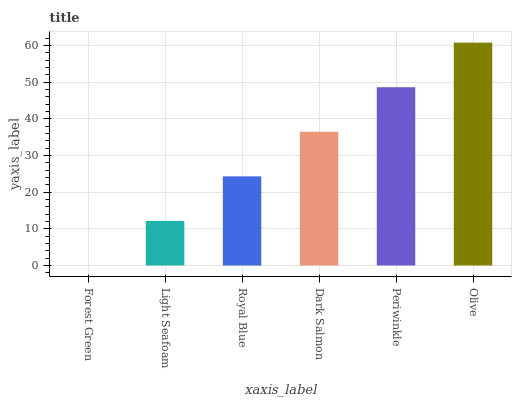Is Forest Green the minimum?
Answer yes or no. Yes. Is Olive the maximum?
Answer yes or no. Yes. Is Light Seafoam the minimum?
Answer yes or no. No. Is Light Seafoam the maximum?
Answer yes or no. No. Is Light Seafoam greater than Forest Green?
Answer yes or no. Yes. Is Forest Green less than Light Seafoam?
Answer yes or no. Yes. Is Forest Green greater than Light Seafoam?
Answer yes or no. No. Is Light Seafoam less than Forest Green?
Answer yes or no. No. Is Dark Salmon the high median?
Answer yes or no. Yes. Is Royal Blue the low median?
Answer yes or no. Yes. Is Periwinkle the high median?
Answer yes or no. No. Is Olive the low median?
Answer yes or no. No. 